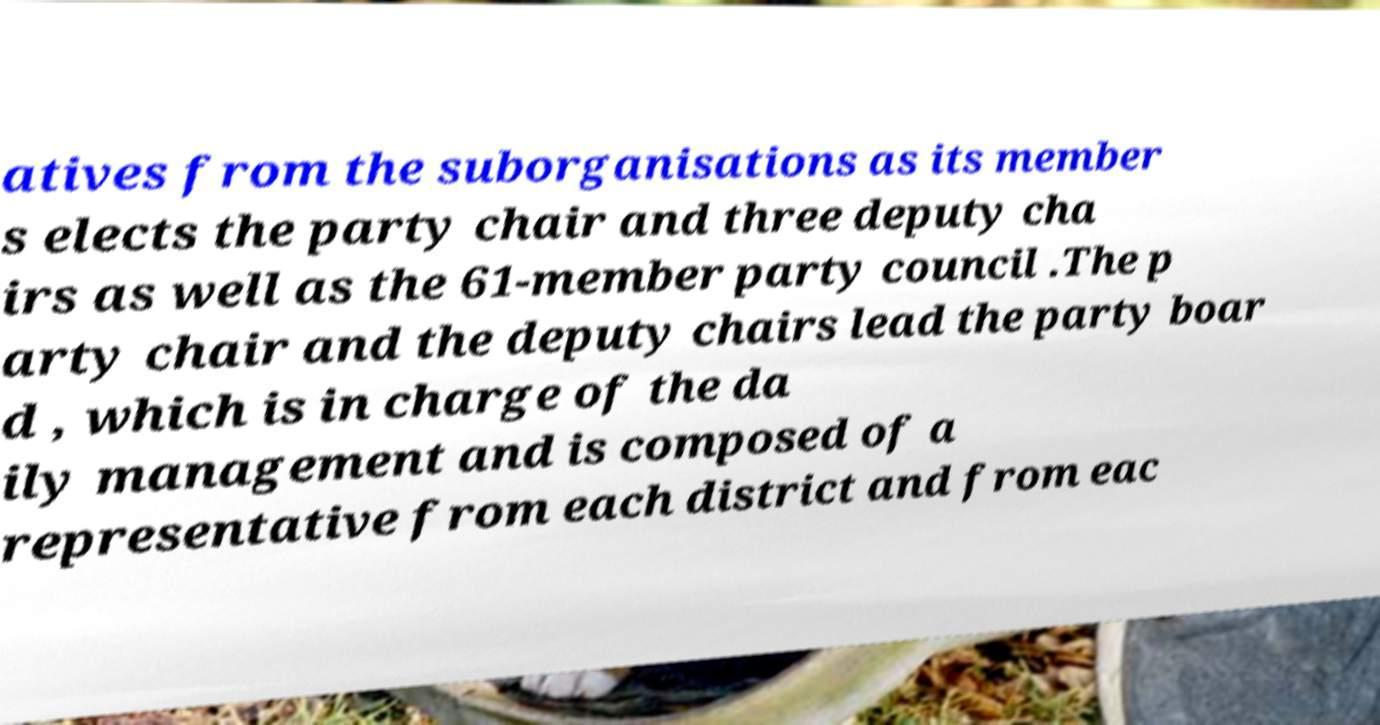Could you extract and type out the text from this image? atives from the suborganisations as its member s elects the party chair and three deputy cha irs as well as the 61-member party council .The p arty chair and the deputy chairs lead the party boar d , which is in charge of the da ily management and is composed of a representative from each district and from eac 